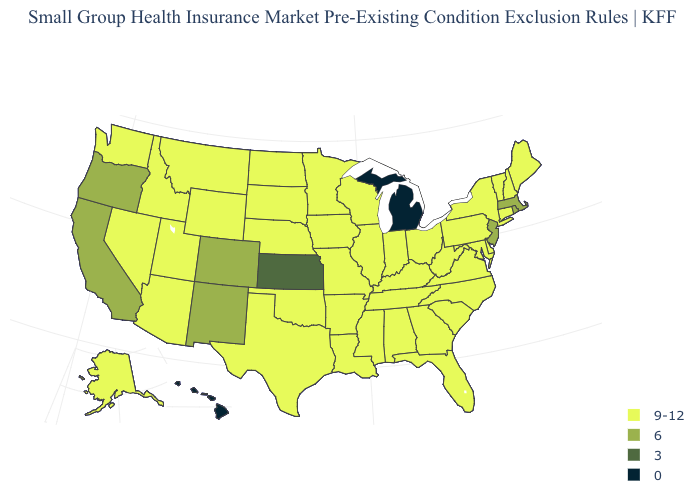Does Maryland have the same value as Georgia?
Be succinct. Yes. How many symbols are there in the legend?
Write a very short answer. 4. What is the value of New Jersey?
Quick response, please. 6. What is the highest value in states that border Wyoming?
Concise answer only. 9-12. What is the highest value in the USA?
Quick response, please. 9-12. Name the states that have a value in the range 9-12?
Write a very short answer. Alabama, Alaska, Arizona, Arkansas, Connecticut, Delaware, Florida, Georgia, Idaho, Illinois, Indiana, Iowa, Kentucky, Louisiana, Maine, Maryland, Minnesota, Mississippi, Missouri, Montana, Nebraska, Nevada, New Hampshire, New York, North Carolina, North Dakota, Ohio, Oklahoma, Pennsylvania, South Carolina, South Dakota, Tennessee, Texas, Utah, Vermont, Virginia, Washington, West Virginia, Wisconsin, Wyoming. Name the states that have a value in the range 3?
Write a very short answer. Kansas. Does South Dakota have the lowest value in the USA?
Give a very brief answer. No. What is the highest value in the Northeast ?
Be succinct. 9-12. What is the highest value in the USA?
Short answer required. 9-12. Is the legend a continuous bar?
Be succinct. No. Name the states that have a value in the range 9-12?
Write a very short answer. Alabama, Alaska, Arizona, Arkansas, Connecticut, Delaware, Florida, Georgia, Idaho, Illinois, Indiana, Iowa, Kentucky, Louisiana, Maine, Maryland, Minnesota, Mississippi, Missouri, Montana, Nebraska, Nevada, New Hampshire, New York, North Carolina, North Dakota, Ohio, Oklahoma, Pennsylvania, South Carolina, South Dakota, Tennessee, Texas, Utah, Vermont, Virginia, Washington, West Virginia, Wisconsin, Wyoming. Name the states that have a value in the range 3?
Quick response, please. Kansas. Name the states that have a value in the range 3?
Short answer required. Kansas. Does New York have the lowest value in the Northeast?
Quick response, please. No. 